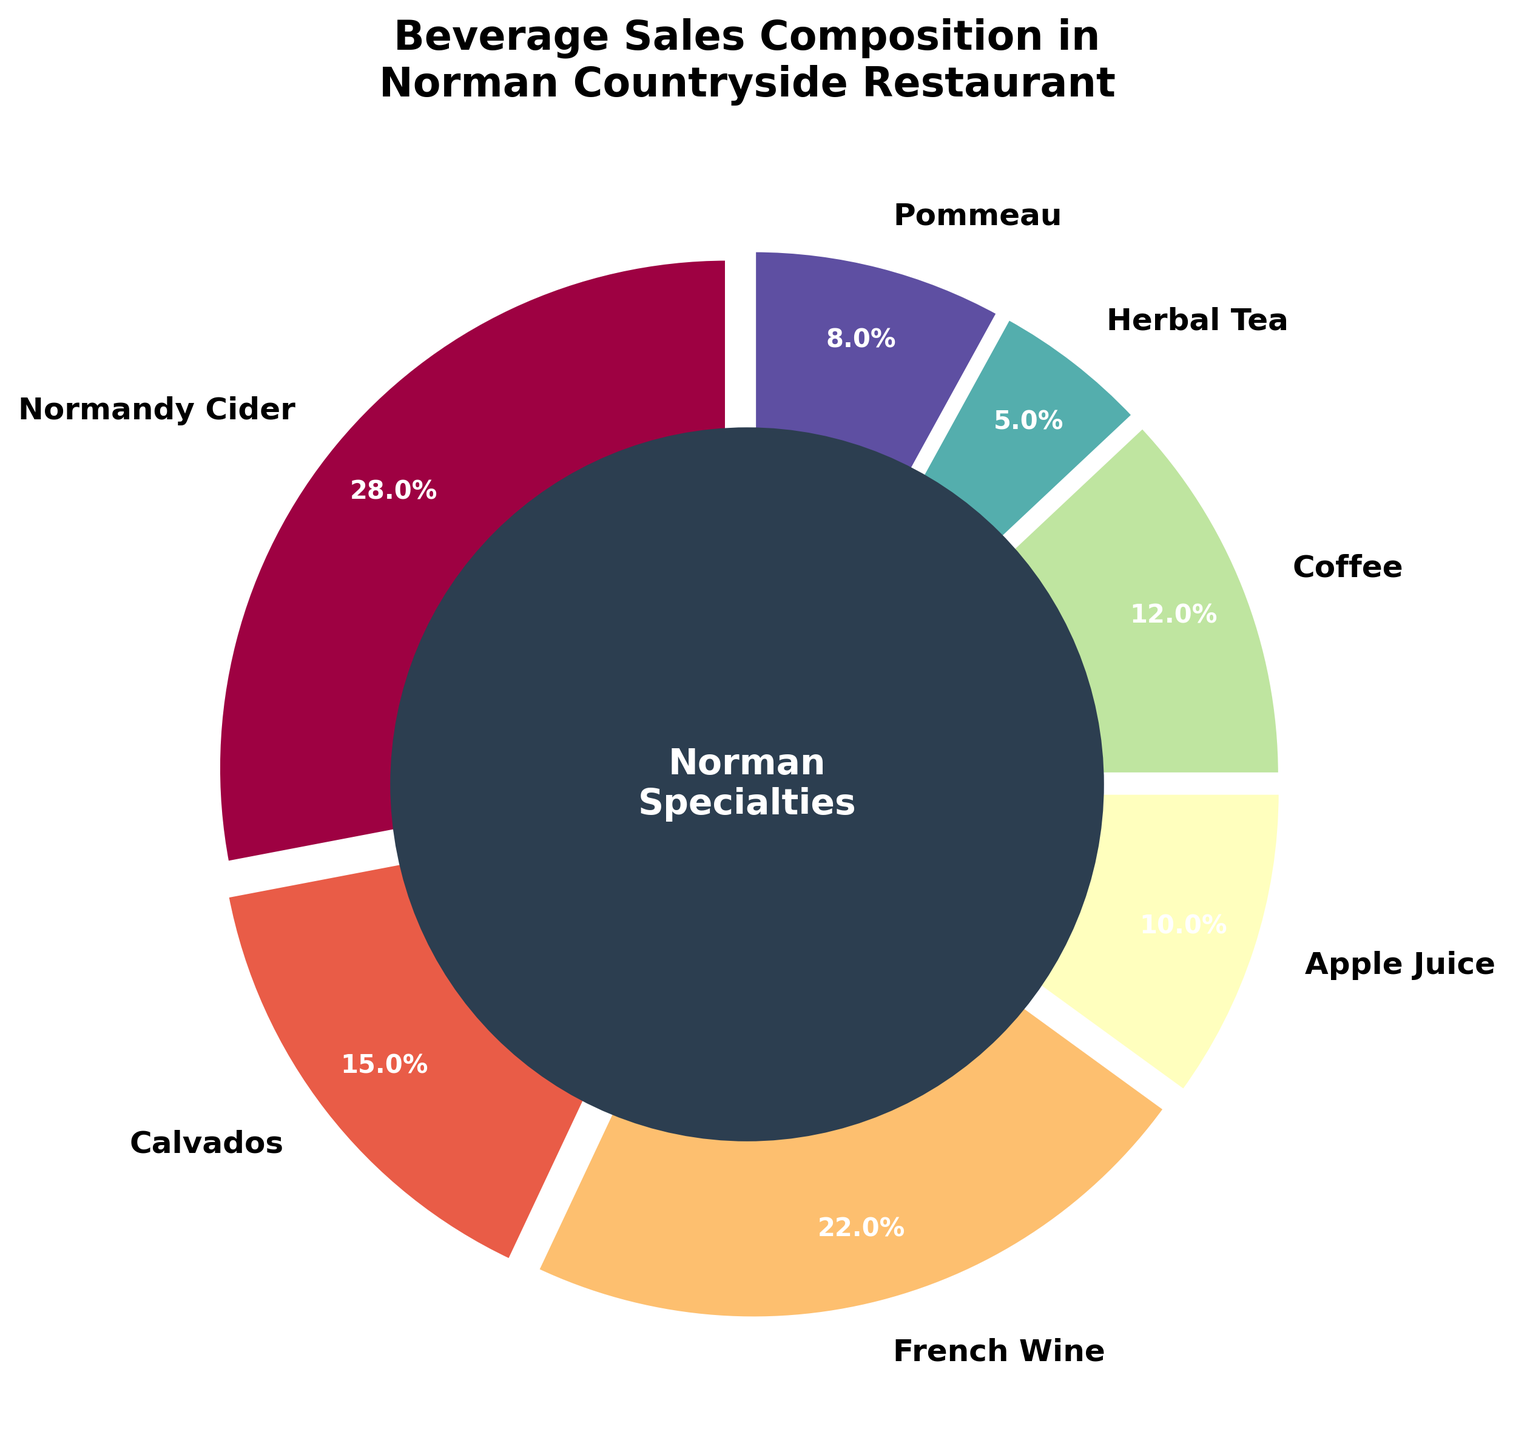What percentage of beverage sales is contributed by Normandy Cider and French Wine combined? Normandy Cider contributes 28% and French Wine contributes 22%. Adding these two percentages together gives 28% + 22% = 50%.
Answer: 50% Which beverage type has the lowest sales percentage, and what is that percentage? By observing the pie chart, Herbal Tea has the smallest segment. The percentage next to Herbal Tea is 5%.
Answer: Herbal Tea, 5% Is the sales percentage of Normandy Cider greater than the combined sales percentage of Apple Juice and Herbal Tea? Normandy Cider has 28%. Apple Juice and Herbal Tea combined have 10% + 5% = 15%. Comparing these, 28% is greater than 15%.
Answer: Yes How much less is the coffee sales percentage compared to Normandy Cider? Normandy Cider has 28%, and Coffee has 12%. The difference is 28% - 12% = 16%.
Answer: 16% What is the difference in sales percentage between the beverage with the highest sales and the one with the lowest sales? The highest percentage is Normandy Cider with 28%, and the lowest is Herbal Tea with 5%. The difference is 28% - 5% = 23%.
Answer: 23% How many beverages have a sales percentage greater than 10%? Observing the pie chart, Normandy Cider, Calvados, French Wine, and Coffee all have percentages greater than 10%. This makes a total of 4 beverages.
Answer: 4 Are the combined sales percentages of Apple Juice and Pommeau greater than or equal to the sales percentage of French Wine? Apple Juice has 10%, and Pommeau has 8%. Combined, they sum to 10% + 8% = 18%. French Wine alone has 22%. 18% is less than 22%.
Answer: No What percentage of sales is contributed by the beverages other than Normandy Cider and French Wine? Excluding Normandy Cider (28%) and French Wine (22%), the remaining percentages are Calvados (15%), Apple Juice (10%), Coffee (12%), Herbal Tea (5%), and Pommeau (8%). Adding these gives 15% + 10% + 12% + 5% + 8% = 50%.
Answer: 50% If you were to double the sales percentage of Pommeau, would it surpass Calvados? Pommeau currently has 8%. Doubling it would make it 8% * 2 = 16%. Calvados has 15%, thus 16% is greater than 15%.
Answer: Yes Which beverage type's segment color closely resembles shades in the purple region? Observing the pie chart and the associated color schemes, Calvados appears to use a shade closely resembling purple and is labeled as 15%.
Answer: Calvados 